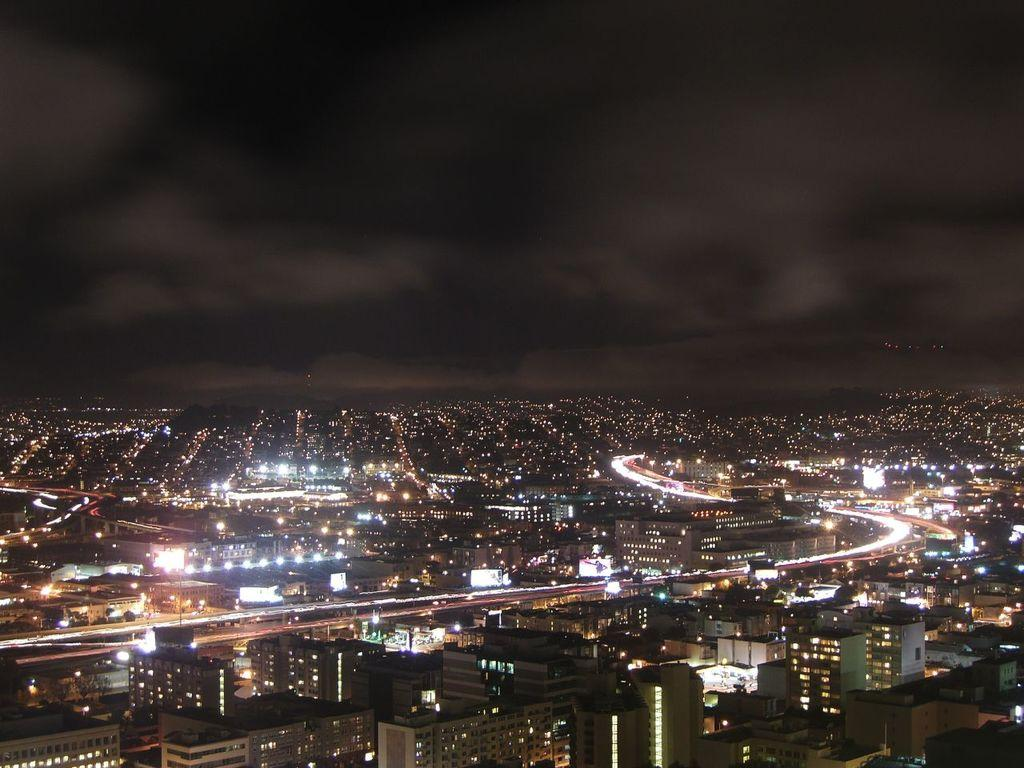What is the lighting condition in the image? The image was clicked in the dark. What can be seen at the bottom of the image? There are many buildings and lights visible. What is visible at the top of the image? The sky is visible at the top of the image. How much profit did the writer make from the image? There is no writer or profit mentioned in the image, as it only shows buildings, lights, and the sky. --- 